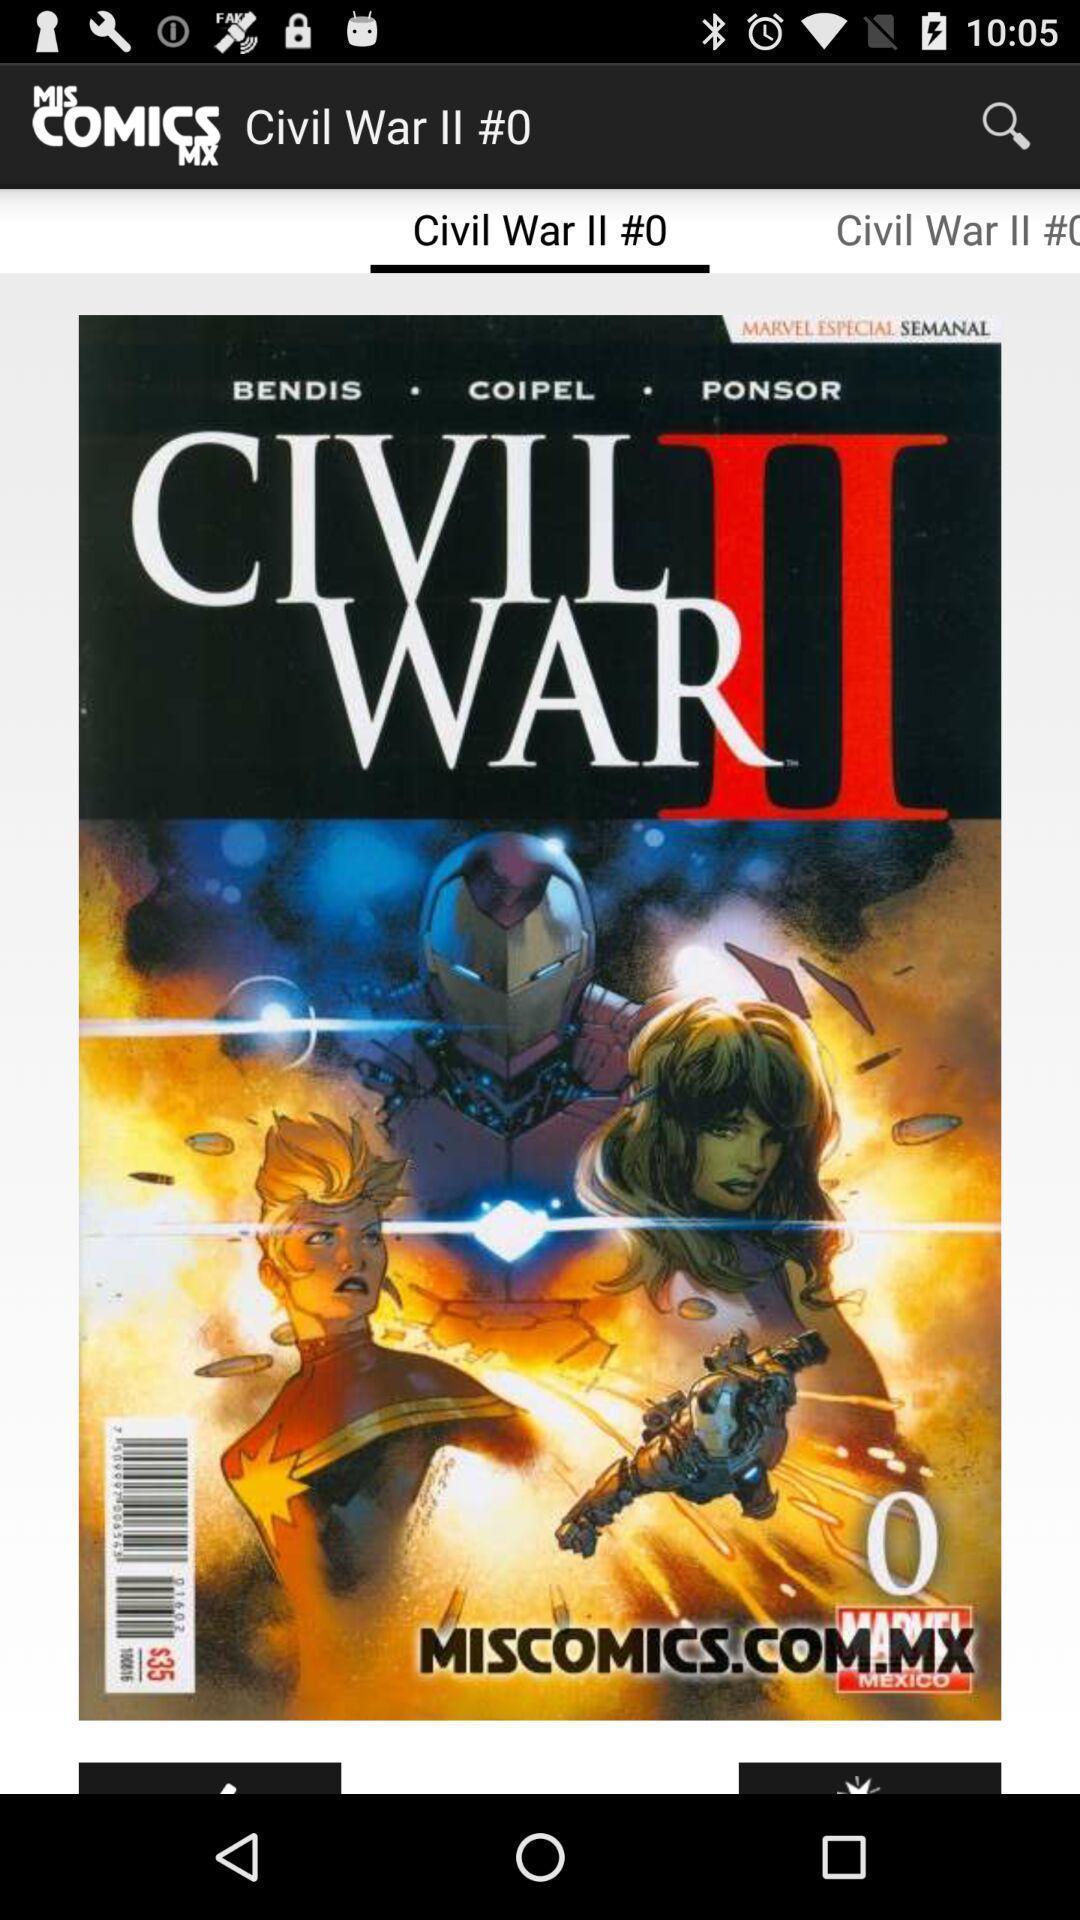Describe this image in words. Screen showing a comic book page of an e-comics app. 